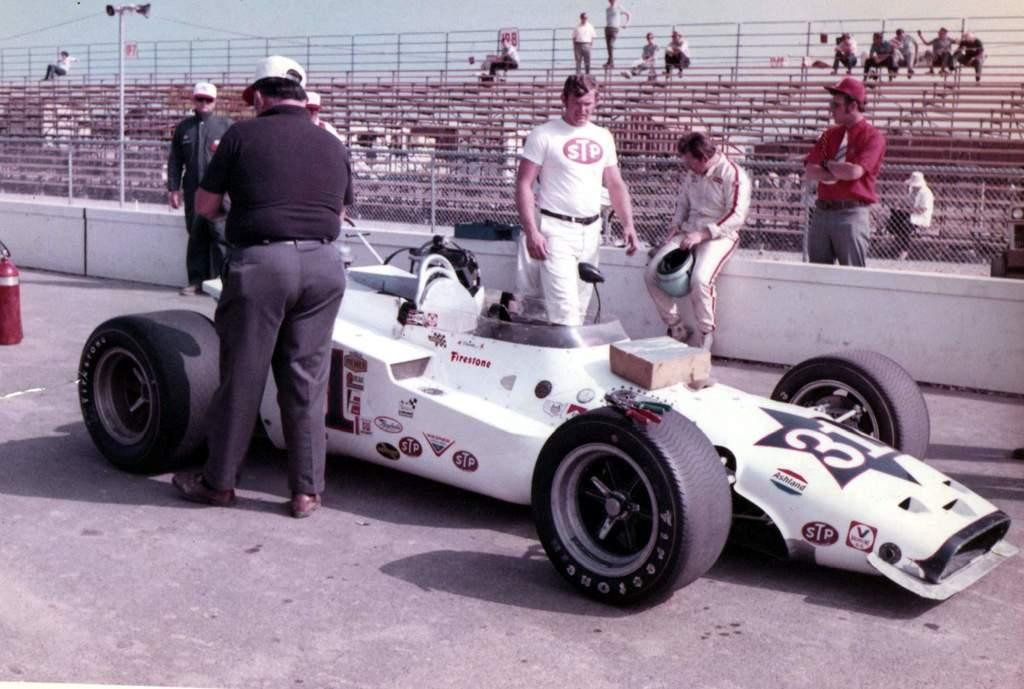What is the main subject of the image? There is a vehicle in the image. What are the people in the image doing? There are persons on a road in the image, and one person is sitting on a white wall. Can you describe the background of the image? There are other persons, fences, poles, and the sky visible in the background of the image. What type of powder is being used by the person sitting on the wall in the image? There is no indication in the image that any powder is being used by the person sitting on the wall. 